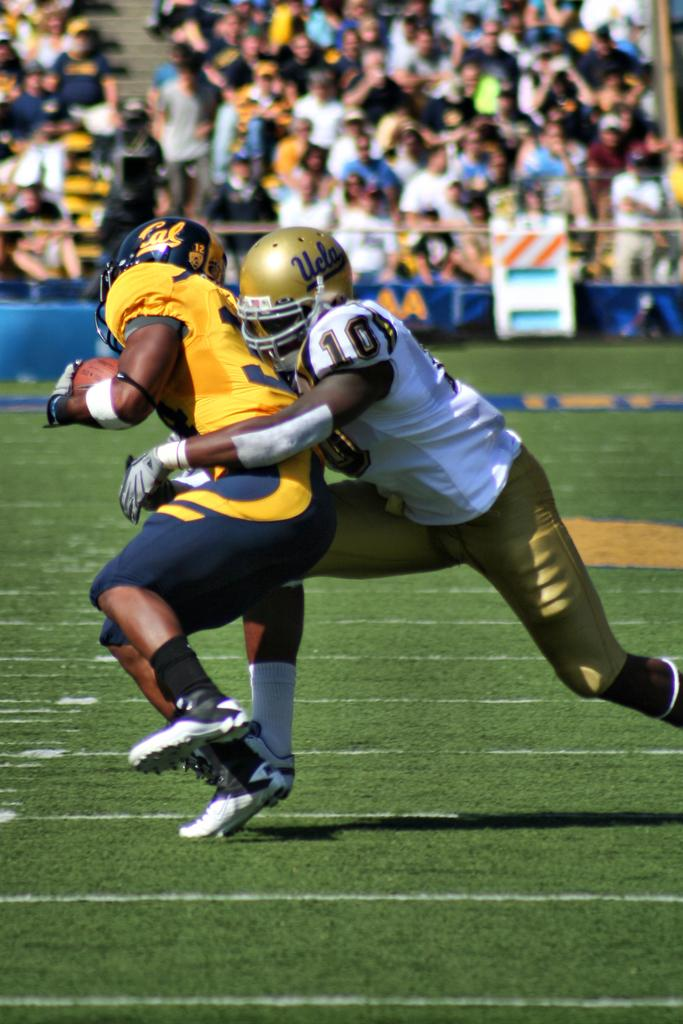How many people are on the ground in the image? There are two people on the ground in the image. Can you describe the people in the background of the image? There are other people visible in the background of the image. What type of dust can be seen on the people in the image? There is no dust visible on the people in the image. Are the people in the image taking a bath together? There is no indication of a bath or any water-related activity in the image. 